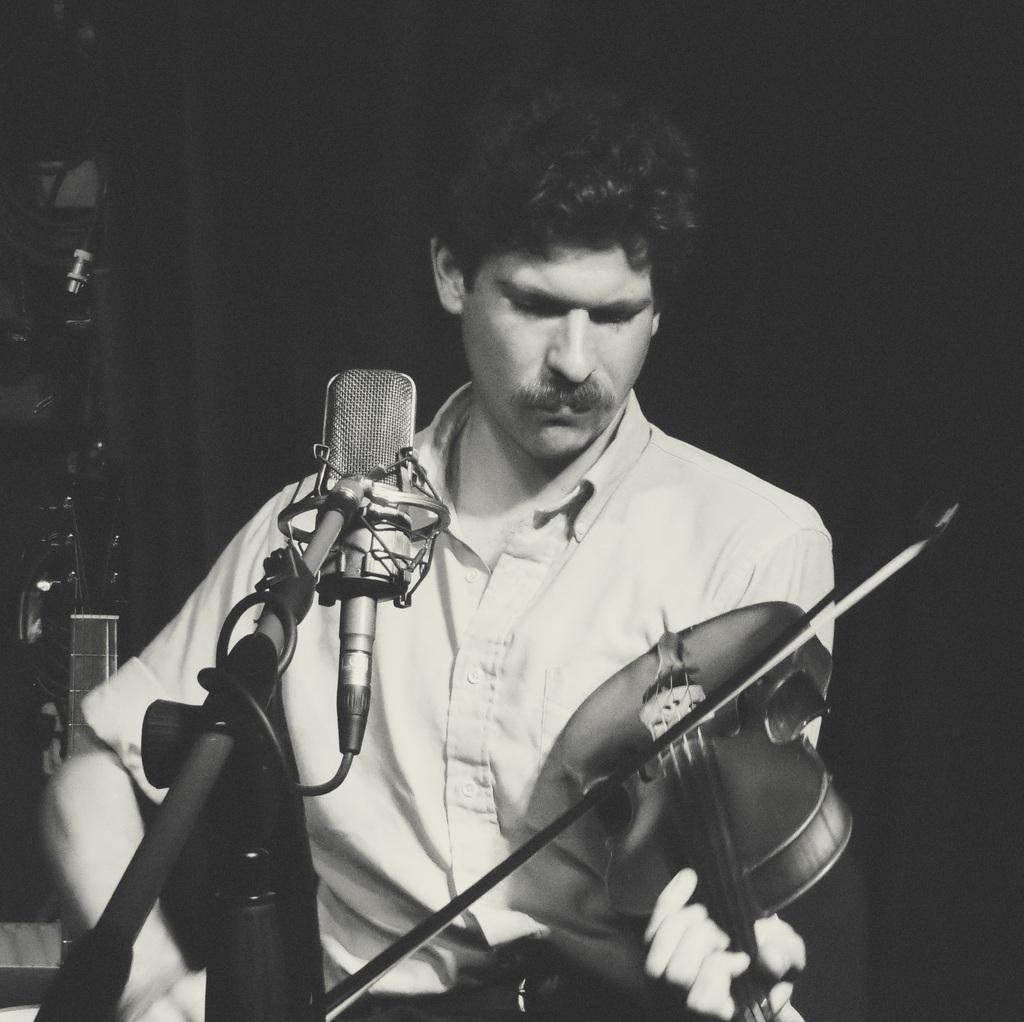What is the main subject of the image? There is a person in the image. What is the person doing in the image? The person is standing and playing the violin. What object is present in the image that is typically used for amplifying sound? There is a microphone in the image. What color scheme is used in the image? The image is in black and white. What type of button can be seen on the person's shirt in the image? There is no button visible on the person's shirt in the image. What holiday is being celebrated in the image? There is no indication of a holiday being celebrated in the image. What is the condition of the person's elbow in the image? There is no visible detail about the person's elbow in the image. 